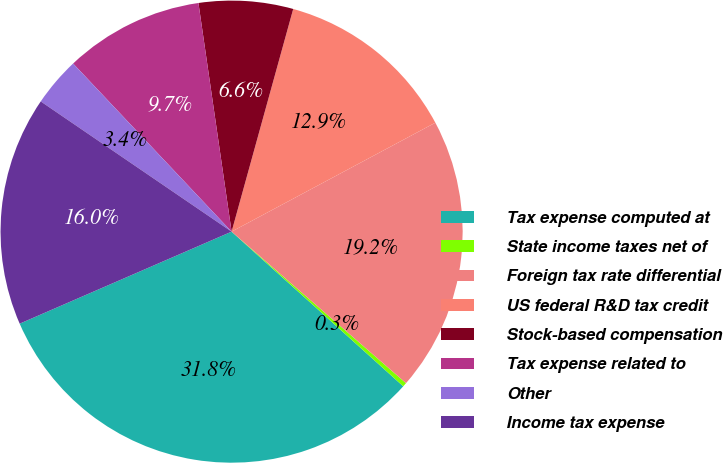Convert chart to OTSL. <chart><loc_0><loc_0><loc_500><loc_500><pie_chart><fcel>Tax expense computed at<fcel>State income taxes net of<fcel>Foreign tax rate differential<fcel>US federal R&D tax credit<fcel>Stock-based compensation<fcel>Tax expense related to<fcel>Other<fcel>Income tax expense<nl><fcel>31.81%<fcel>0.29%<fcel>19.2%<fcel>12.89%<fcel>6.59%<fcel>9.74%<fcel>3.44%<fcel>16.05%<nl></chart> 